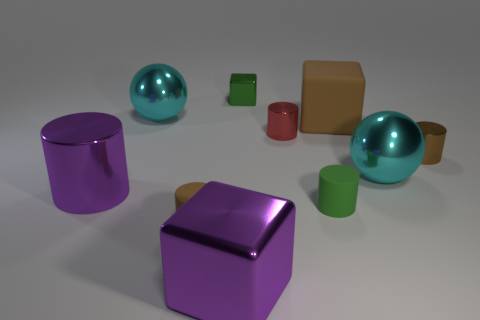Subtract all purple cylinders. How many cylinders are left? 4 Subtract all purple cylinders. How many cylinders are left? 4 Subtract all gray cylinders. Subtract all purple cubes. How many cylinders are left? 5 Subtract all balls. How many objects are left? 8 Subtract 0 purple balls. How many objects are left? 10 Subtract all large cubes. Subtract all green objects. How many objects are left? 6 Add 7 tiny green things. How many tiny green things are left? 9 Add 4 tiny brown metallic things. How many tiny brown metallic things exist? 5 